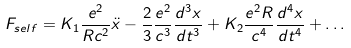Convert formula to latex. <formula><loc_0><loc_0><loc_500><loc_500>F _ { s e l f } = K _ { 1 } \frac { e ^ { 2 } } { R c ^ { 2 } } \ddot { x } - \frac { 2 } { 3 } \frac { e ^ { 2 } } { c ^ { 3 } } \frac { d ^ { 3 } x } { d t ^ { 3 } } + K _ { 2 } \frac { e ^ { 2 } R } { c ^ { 4 } } \frac { d ^ { 4 } x } { d t ^ { 4 } } + \dots</formula> 